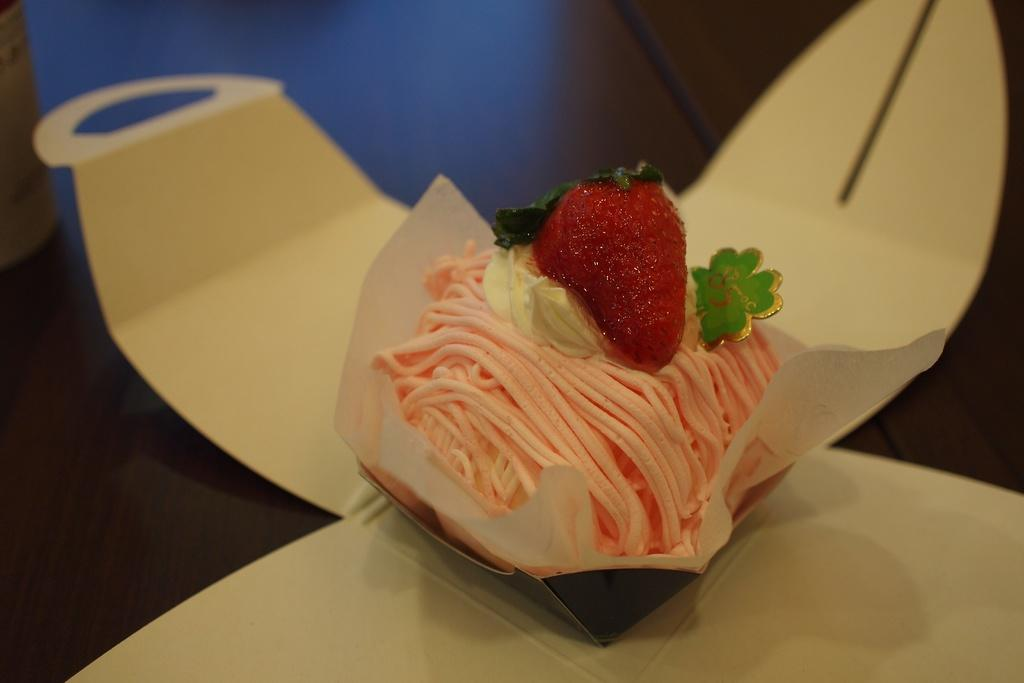What is the main object in the center of the image? There is a box in the center of the image. What type of food item can be seen in the image? There is a pastry in the image. What piece of furniture is at the bottom of the image? There is a table at the bottom of the image. What type of lead is being used to transport the pastry in the image? There is no lead or transportation depicted in the image; it only shows a box, a pastry, and a table. 